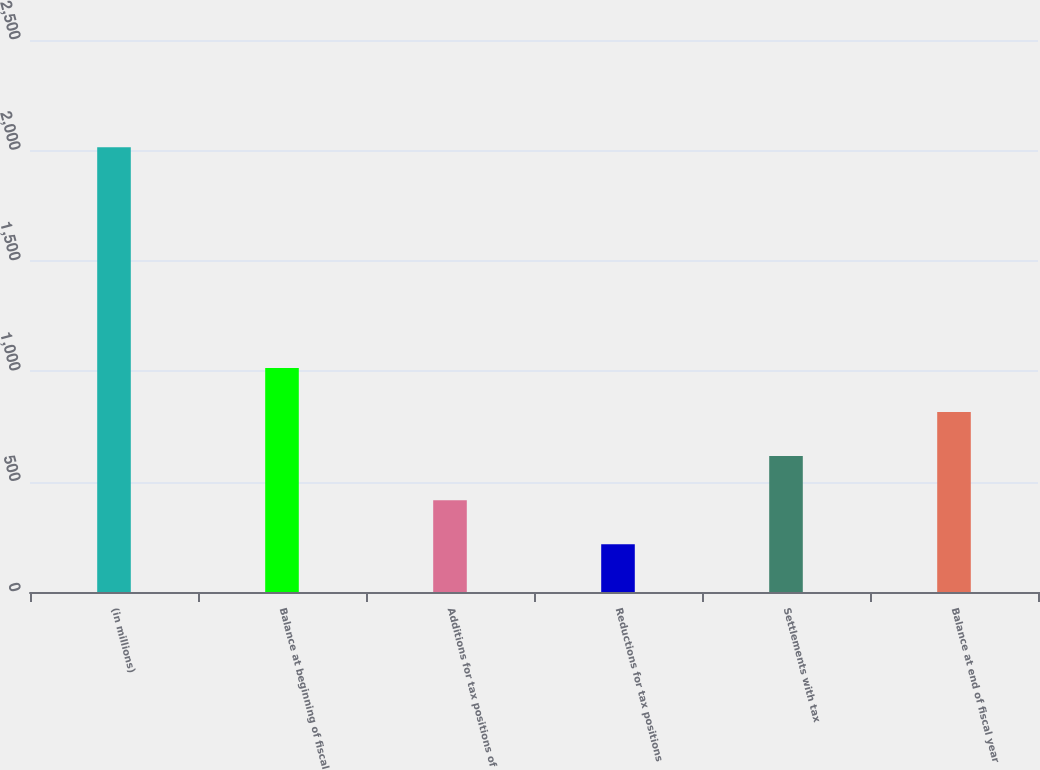Convert chart to OTSL. <chart><loc_0><loc_0><loc_500><loc_500><bar_chart><fcel>(in millions)<fcel>Balance at beginning of fiscal<fcel>Additions for tax positions of<fcel>Reductions for tax positions<fcel>Settlements with tax<fcel>Balance at end of fiscal year<nl><fcel>2014<fcel>1015<fcel>415.6<fcel>215.8<fcel>615.4<fcel>815.2<nl></chart> 